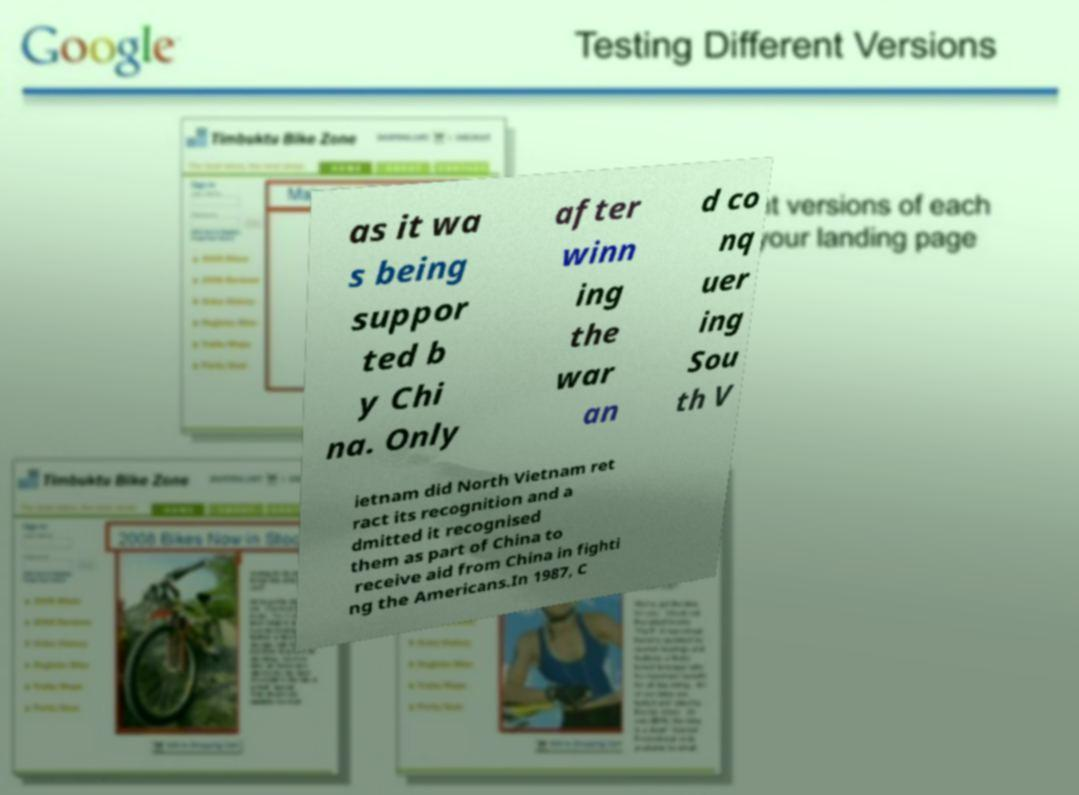Please identify and transcribe the text found in this image. as it wa s being suppor ted b y Chi na. Only after winn ing the war an d co nq uer ing Sou th V ietnam did North Vietnam ret ract its recognition and a dmitted it recognised them as part of China to receive aid from China in fighti ng the Americans.In 1987, C 